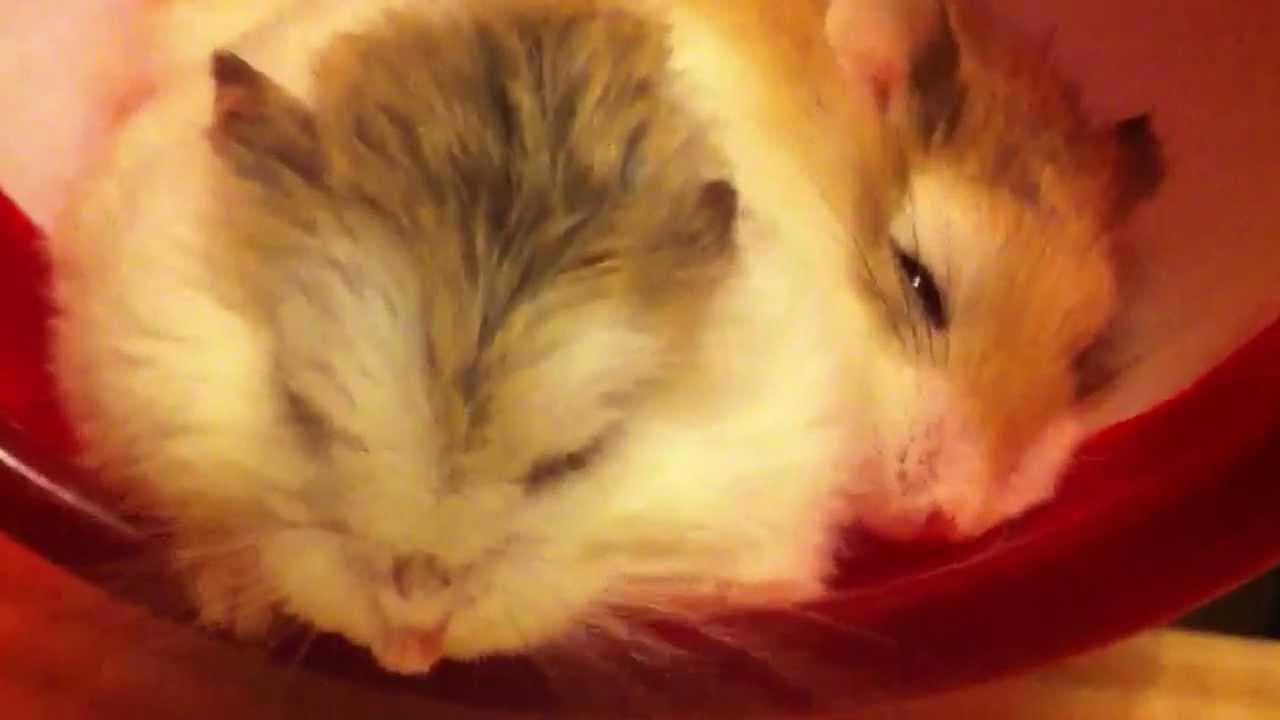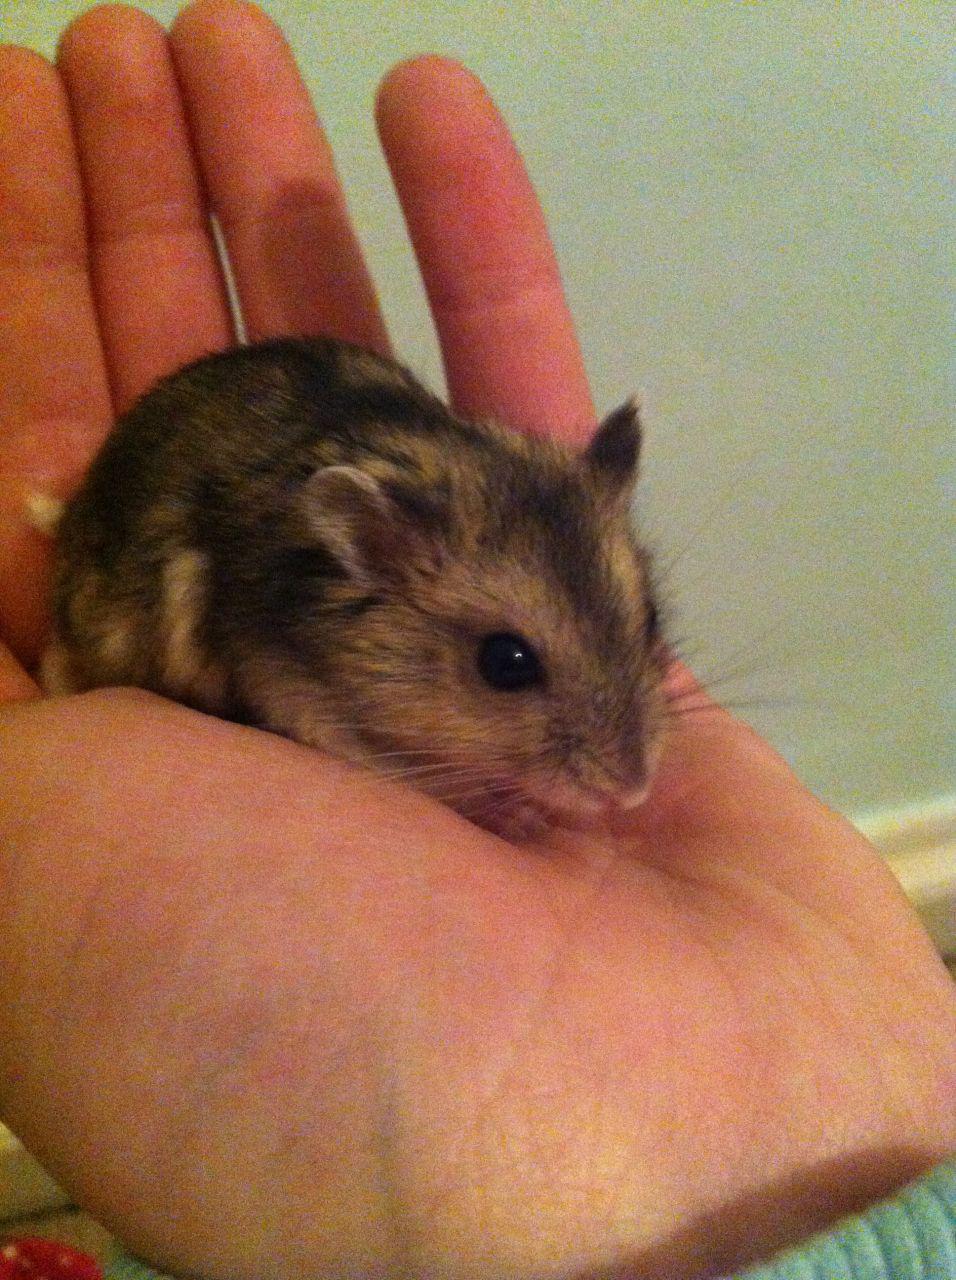The first image is the image on the left, the second image is the image on the right. Evaluate the accuracy of this statement regarding the images: "One image shows side-by-side hamsters, and the other shows one small pet in an upturned palm.". Is it true? Answer yes or no. Yes. The first image is the image on the left, the second image is the image on the right. Assess this claim about the two images: "The right image contains at least two hamsters.". Correct or not? Answer yes or no. No. 